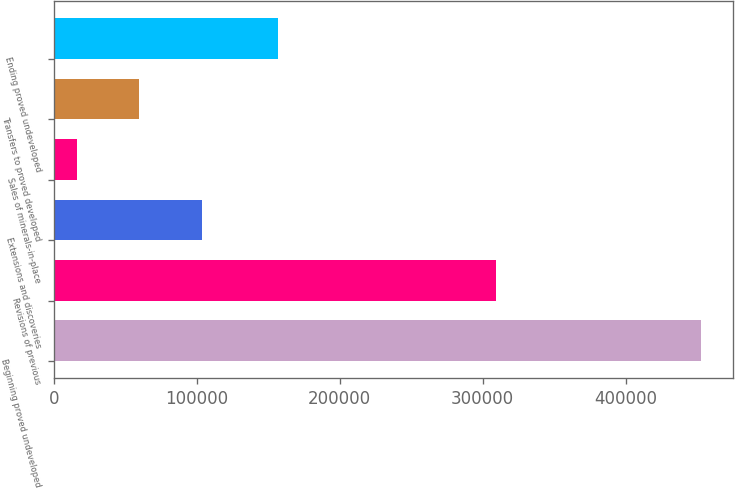<chart> <loc_0><loc_0><loc_500><loc_500><bar_chart><fcel>Beginning proved undeveloped<fcel>Revisions of previous<fcel>Extensions and discoveries<fcel>Sales of minerals-in-place<fcel>Transfers to proved developed<fcel>Ending proved undeveloped<nl><fcel>452789<fcel>309435<fcel>103379<fcel>16026<fcel>59702.3<fcel>156507<nl></chart> 